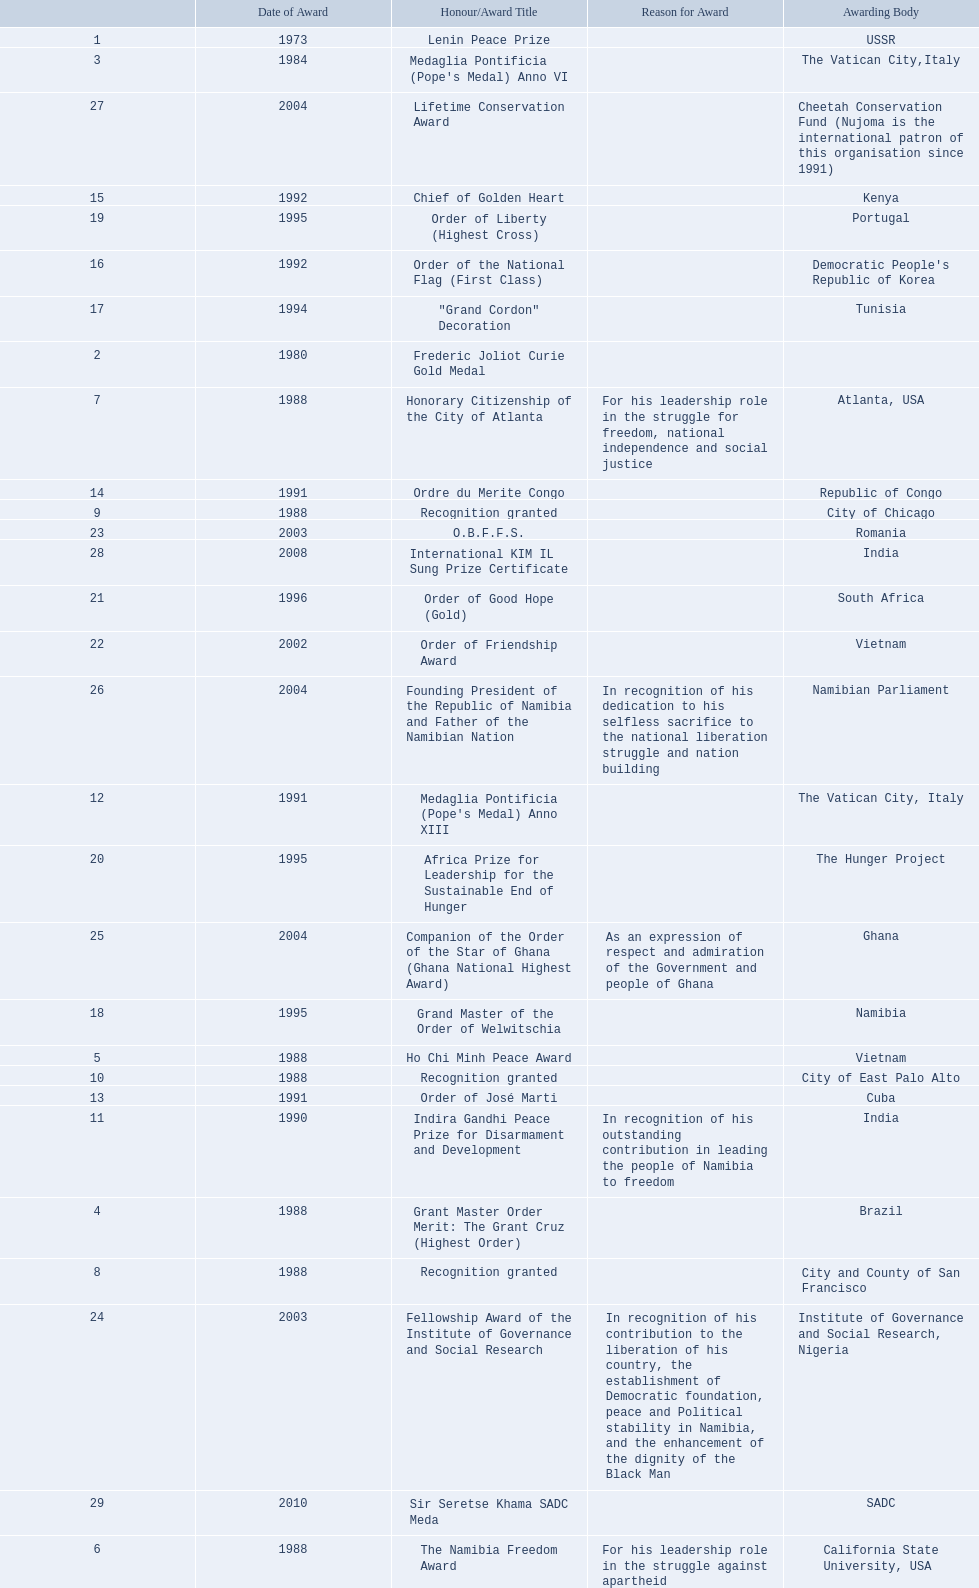What awards did sam nujoma win? 1, 1973, Lenin Peace Prize, Frederic Joliot Curie Gold Medal, Medaglia Pontificia (Pope's Medal) Anno VI, Grant Master Order Merit: The Grant Cruz (Highest Order), Ho Chi Minh Peace Award, The Namibia Freedom Award, Honorary Citizenship of the City of Atlanta, Recognition granted, Recognition granted, Recognition granted, Indira Gandhi Peace Prize for Disarmament and Development, Medaglia Pontificia (Pope's Medal) Anno XIII, Order of José Marti, Ordre du Merite Congo, Chief of Golden Heart, Order of the National Flag (First Class), "Grand Cordon" Decoration, Grand Master of the Order of Welwitschia, Order of Liberty (Highest Cross), Africa Prize for Leadership for the Sustainable End of Hunger, Order of Good Hope (Gold), Order of Friendship Award, O.B.F.F.S., Fellowship Award of the Institute of Governance and Social Research, Companion of the Order of the Star of Ghana (Ghana National Highest Award), Founding President of the Republic of Namibia and Father of the Namibian Nation, Lifetime Conservation Award, International KIM IL Sung Prize Certificate, Sir Seretse Khama SADC Meda. Who was the awarding body for the o.b.f.f.s award? Romania. 